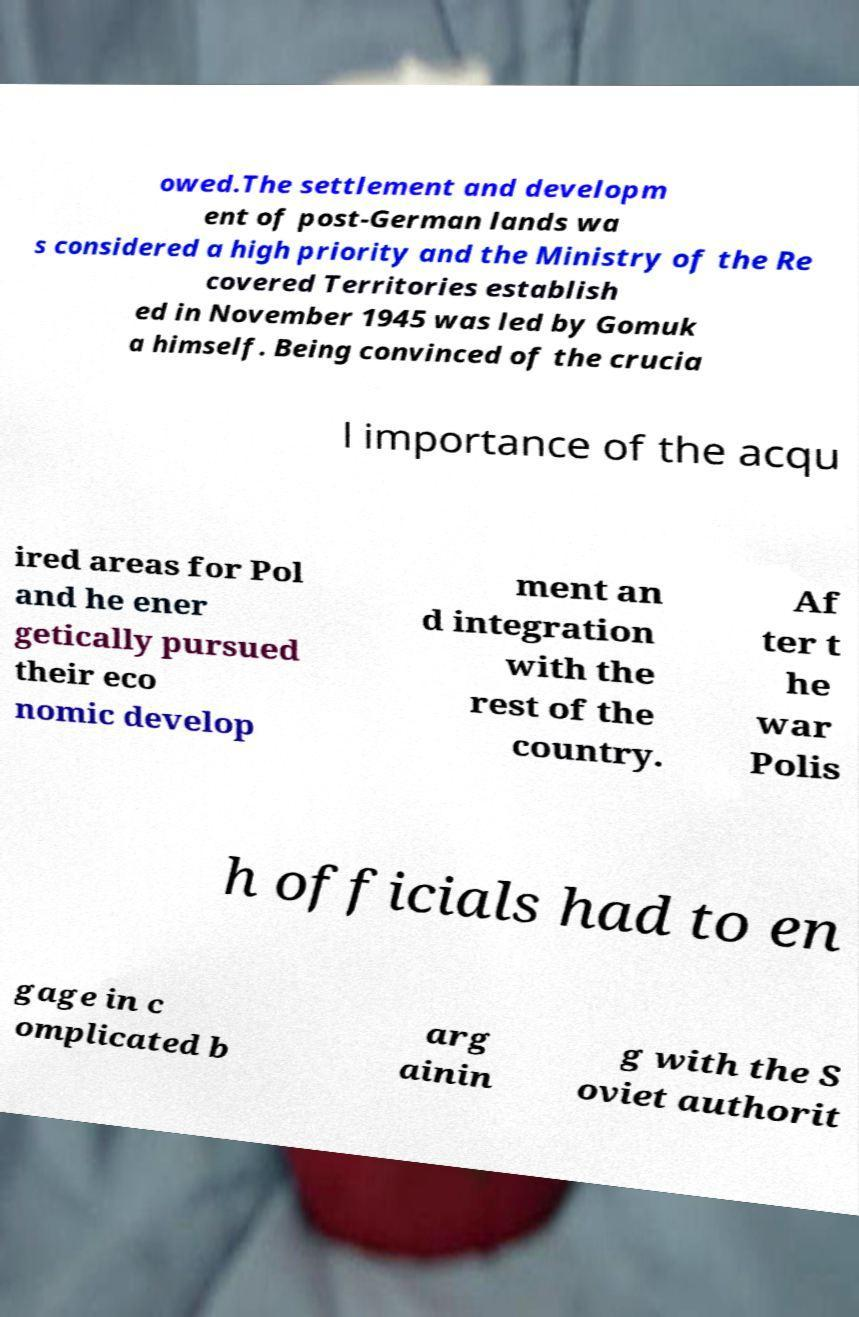I need the written content from this picture converted into text. Can you do that? owed.The settlement and developm ent of post-German lands wa s considered a high priority and the Ministry of the Re covered Territories establish ed in November 1945 was led by Gomuk a himself. Being convinced of the crucia l importance of the acqu ired areas for Pol and he ener getically pursued their eco nomic develop ment an d integration with the rest of the country. Af ter t he war Polis h officials had to en gage in c omplicated b arg ainin g with the S oviet authorit 